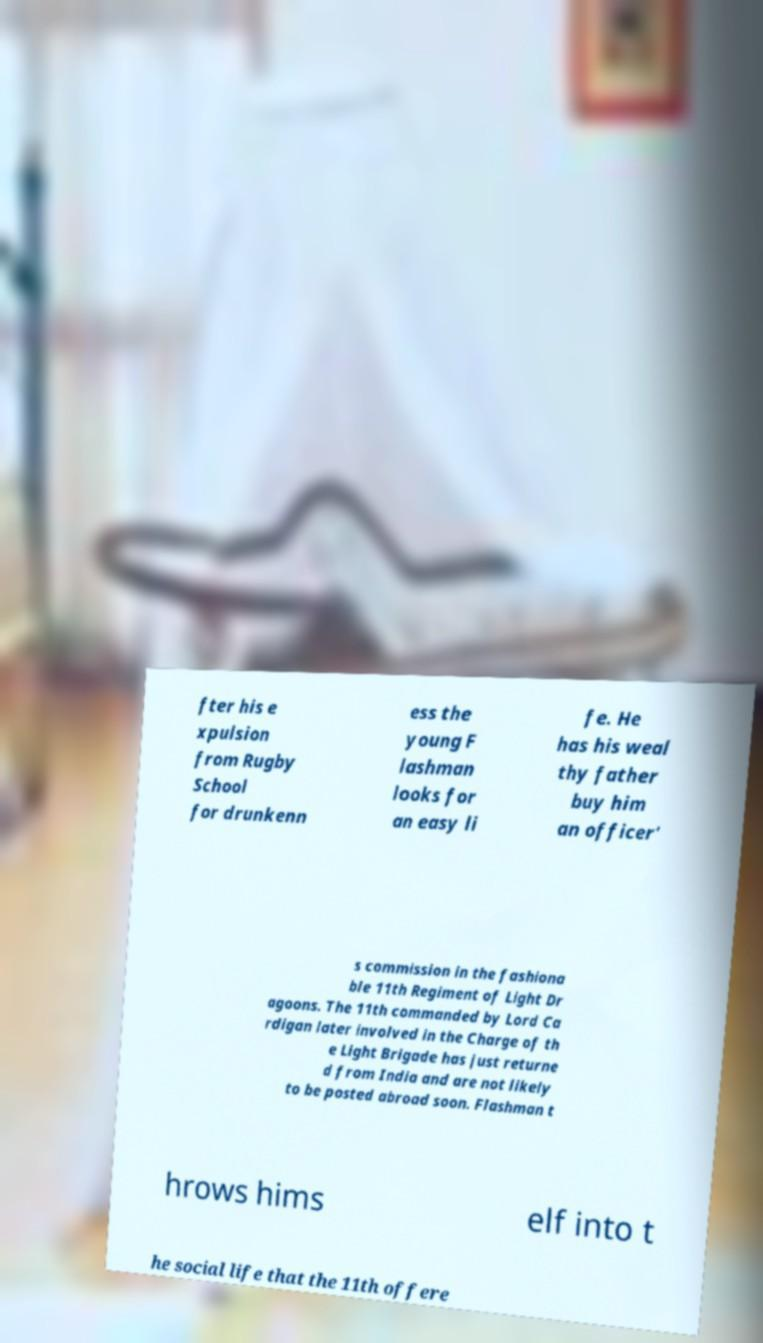I need the written content from this picture converted into text. Can you do that? fter his e xpulsion from Rugby School for drunkenn ess the young F lashman looks for an easy li fe. He has his weal thy father buy him an officer' s commission in the fashiona ble 11th Regiment of Light Dr agoons. The 11th commanded by Lord Ca rdigan later involved in the Charge of th e Light Brigade has just returne d from India and are not likely to be posted abroad soon. Flashman t hrows hims elf into t he social life that the 11th offere 